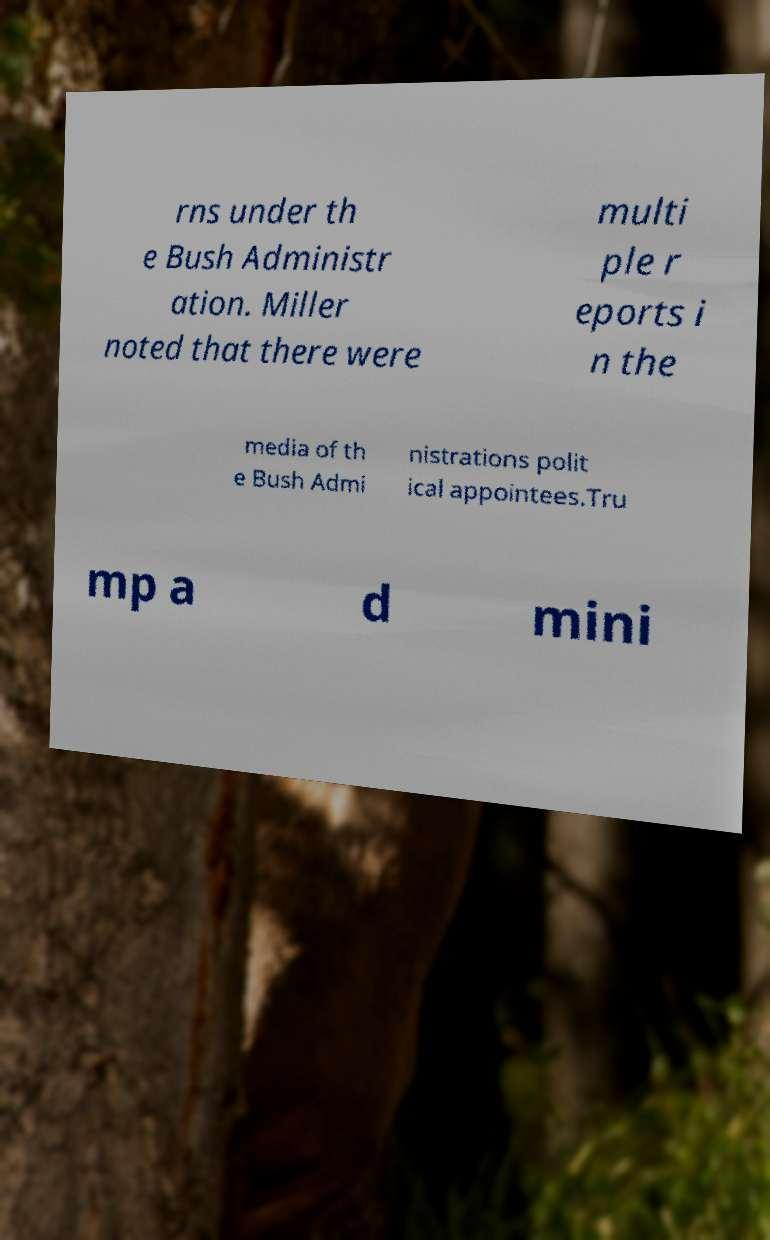I need the written content from this picture converted into text. Can you do that? rns under th e Bush Administr ation. Miller noted that there were multi ple r eports i n the media of th e Bush Admi nistrations polit ical appointees.Tru mp a d mini 